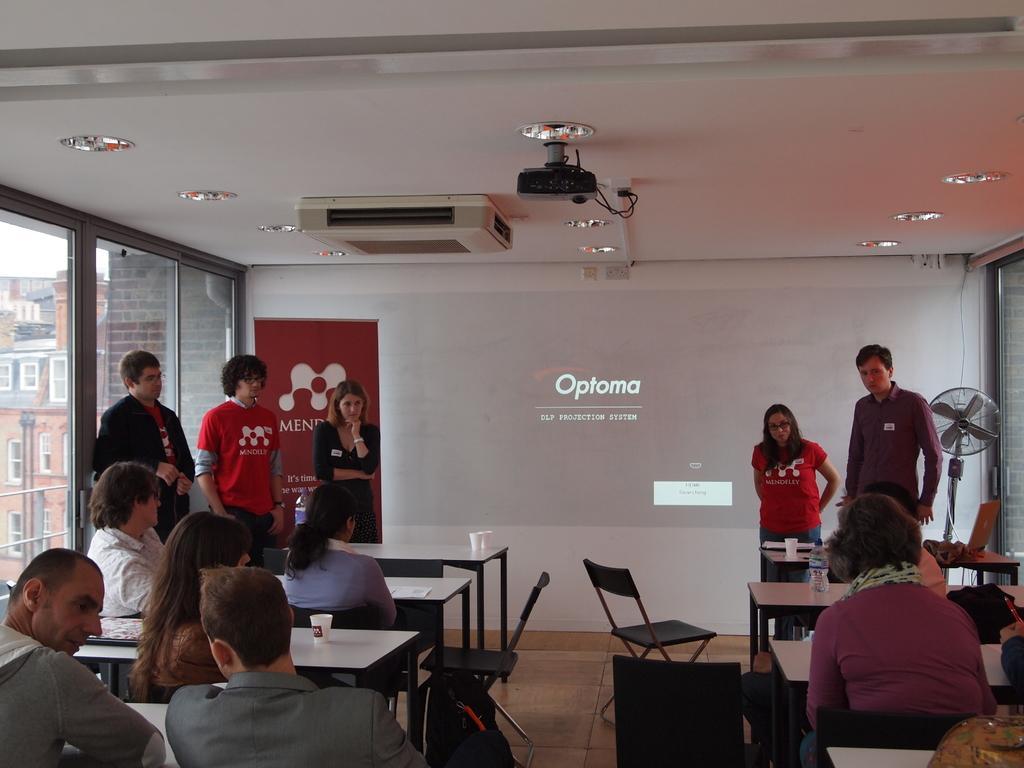Describe this image in one or two sentences. In this image there are group of people sitting on the chairs , there are some objects on the tables, there is a fan , board, projector, there are lights, group of people standing , and in the background there is a building. 